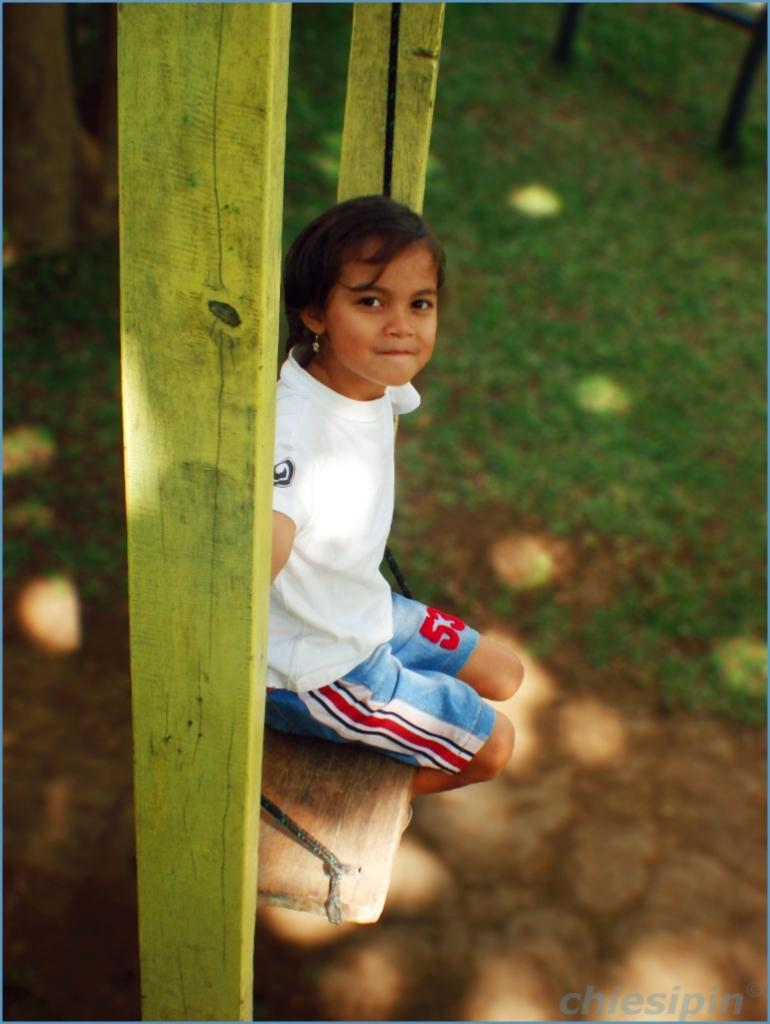<image>
Offer a succinct explanation of the picture presented. A young girl sits on a wooden swing wearing blue shorts with a red number 53 on them. 